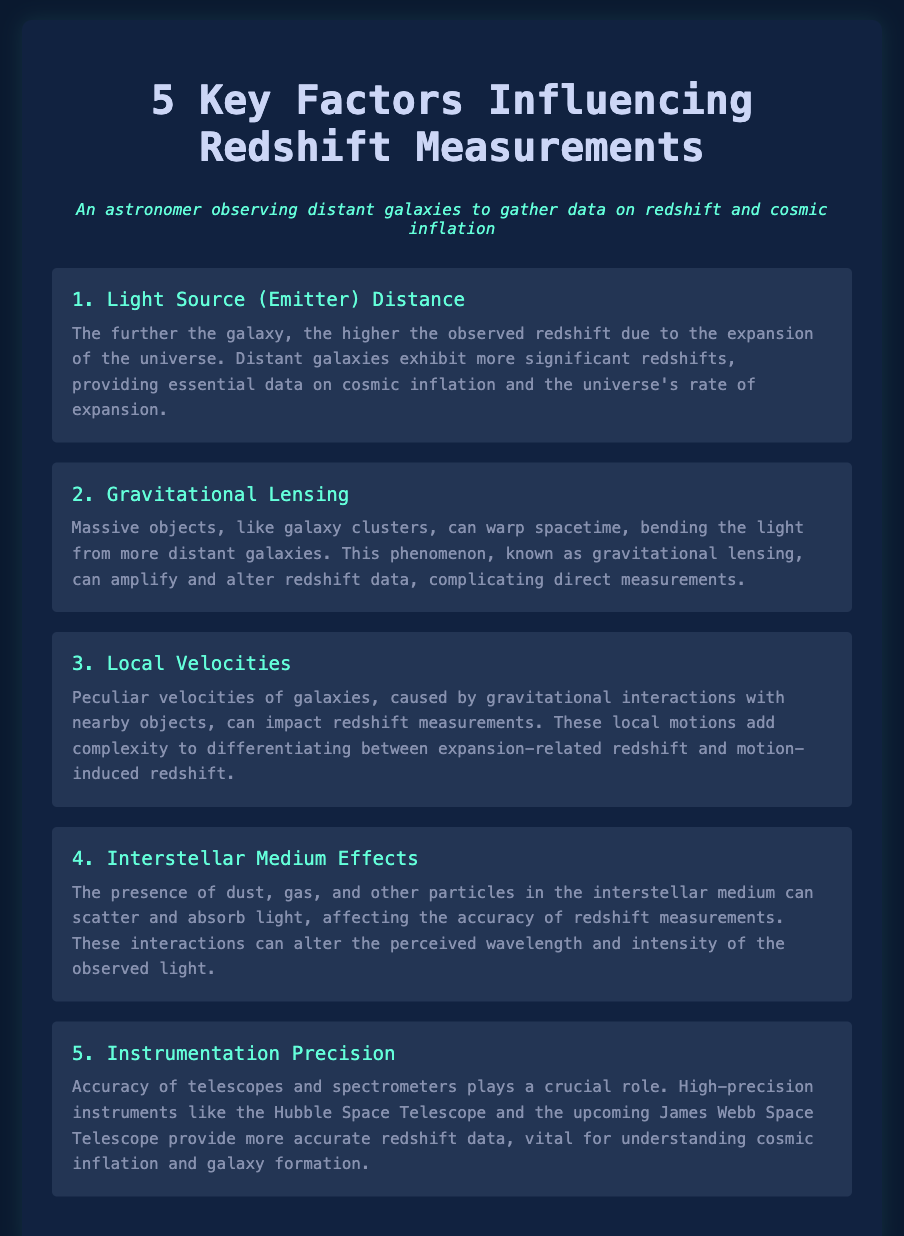What is the first key factor influencing redshift measurements? The first key factor is listed as "Light Source (Emitter) Distance", which indicates how the distance from the galaxy relates to observed redshift.
Answer: Light Source (Emitter) Distance What is the role of gravitational lensing in redshift measurements? Gravitational lensing warps spacetime, bending the light from distant galaxies, which can alter redshift data.
Answer: Alters redshift data What can cause peculiar velocities in galaxies? Peculiar velocities are caused by gravitational interactions with nearby objects, impacting redshift measurements.
Answer: Gravitational interactions How does the interstellar medium affect redshift measurements? The interstellar medium can scatter and absorb light, affecting accuracy in measurements by altering perceived wavelengths.
Answer: Scatters and absorbs light Which telescopes provide more accurate redshift data? The document mentions the Hubble Space Telescope and the upcoming James Webb Space Telescope as high-precision instruments.
Answer: Hubble Space Telescope and James Webb Space Telescope What does a higher observed redshift imply about the galaxy's distance? A higher observed redshift indicates that the galaxy is further away due to the expansion of the universe.
Answer: Further away What are the effects of local velocities on redshift measurements? Local velocities add complexity by blending expansion-related redshift with motion-induced redshift, complicating measurements.
Answer: Adds complexity What is the primary purpose of high-precision instruments in redshift measurements? They provide more accurate redshift data essential for understanding cosmic inflation and galaxy formation.
Answer: More accurate redshift data What does gravitational lensing specifically require to occur? It requires massive objects, like galaxy clusters, to warp spacetime and affect light paths.
Answer: Massive objects 